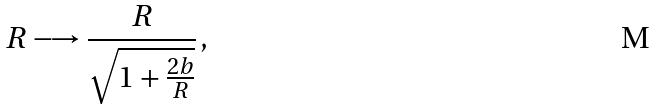<formula> <loc_0><loc_0><loc_500><loc_500>R \longrightarrow \frac { R } { \sqrt { 1 + \frac { 2 b } { R } } } \, ,</formula> 